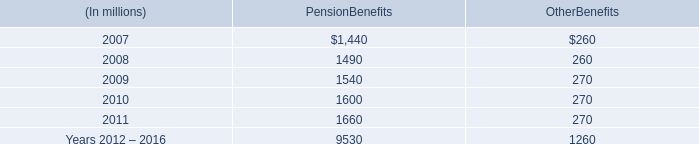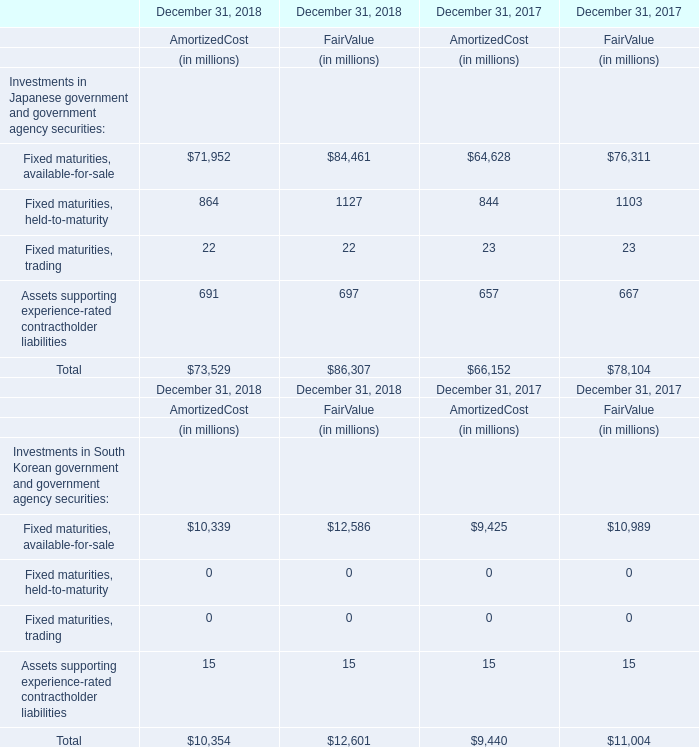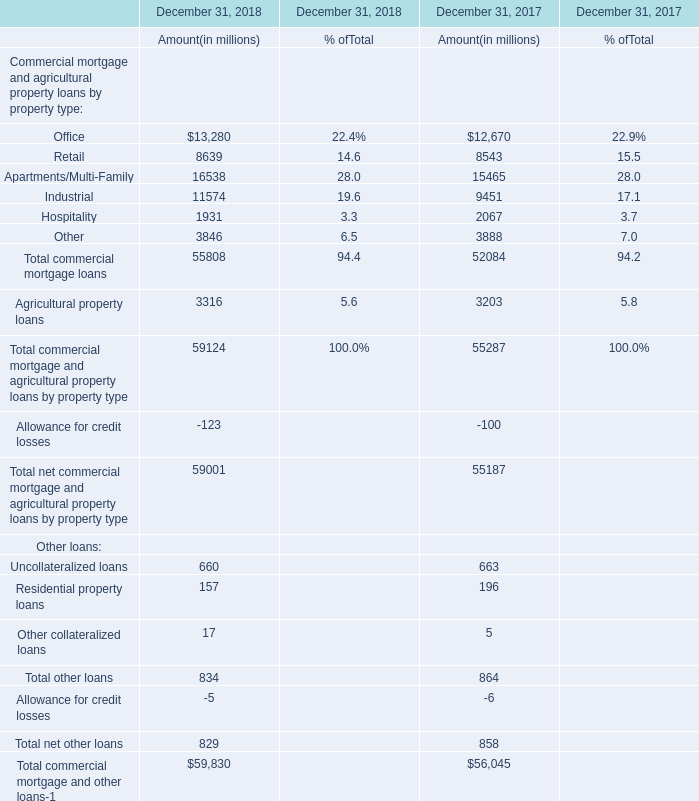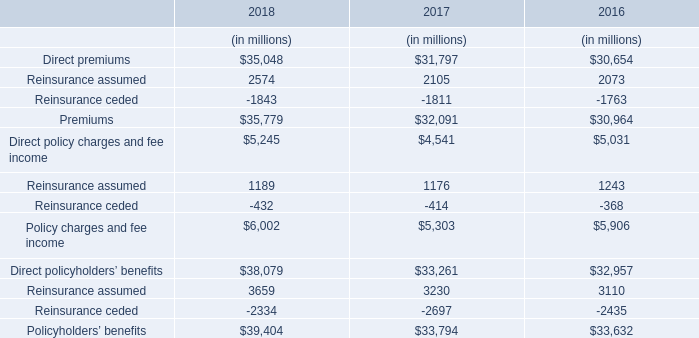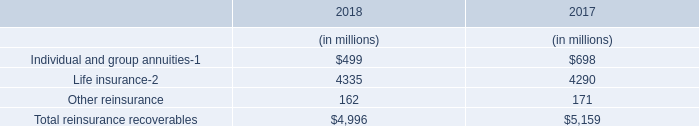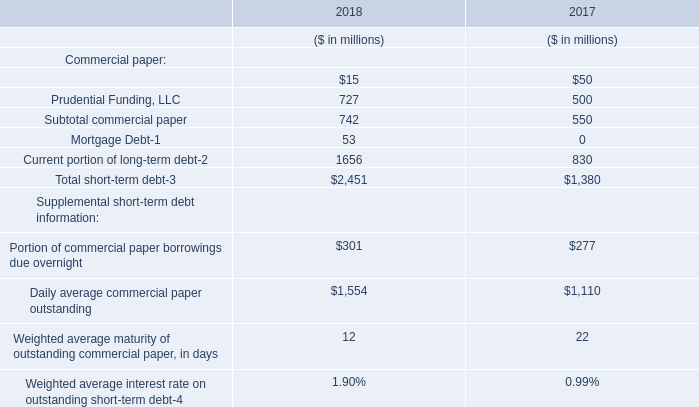As As the chart 1 shows,on December 31 in 2018, what's the increasing rate of the Fair Value for the Investments in Japanese government and government agency securities:Fixed maturities, held-to-maturity? 
Computations: ((1127 - 1103) / 1103)
Answer: 0.02176. 